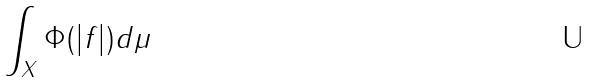Convert formula to latex. <formula><loc_0><loc_0><loc_500><loc_500>\int _ { X } \Phi ( | f | ) d \mu</formula> 